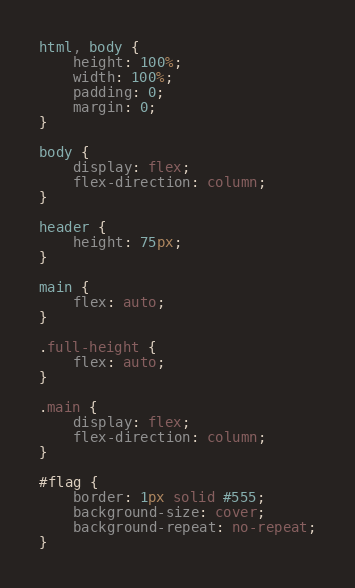Convert code to text. <code><loc_0><loc_0><loc_500><loc_500><_CSS_>html, body {
    height: 100%;
    width: 100%;
    padding: 0;
    margin: 0;
}

body {
    display: flex;
    flex-direction: column;
}

header {
    height: 75px;
}

main {
    flex: auto;
}

.full-height {
    flex: auto;
}

.main {
    display: flex;
    flex-direction: column;
}

#flag {
    border: 1px solid #555;
    background-size: cover;
    background-repeat: no-repeat;
}</code> 